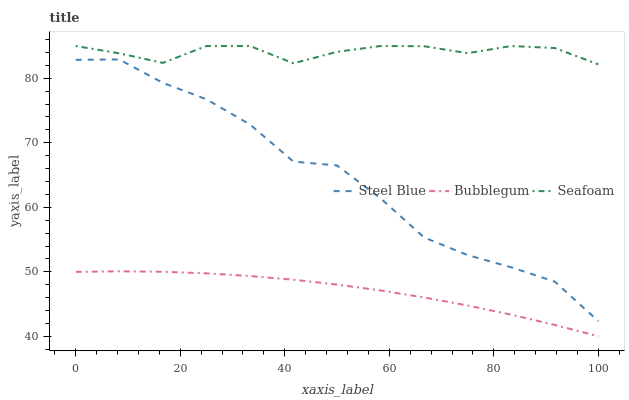Does Seafoam have the minimum area under the curve?
Answer yes or no. No. Does Bubblegum have the maximum area under the curve?
Answer yes or no. No. Is Seafoam the smoothest?
Answer yes or no. No. Is Seafoam the roughest?
Answer yes or no. No. Does Seafoam have the lowest value?
Answer yes or no. No. Does Bubblegum have the highest value?
Answer yes or no. No. Is Steel Blue less than Seafoam?
Answer yes or no. Yes. Is Seafoam greater than Bubblegum?
Answer yes or no. Yes. Does Steel Blue intersect Seafoam?
Answer yes or no. No. 